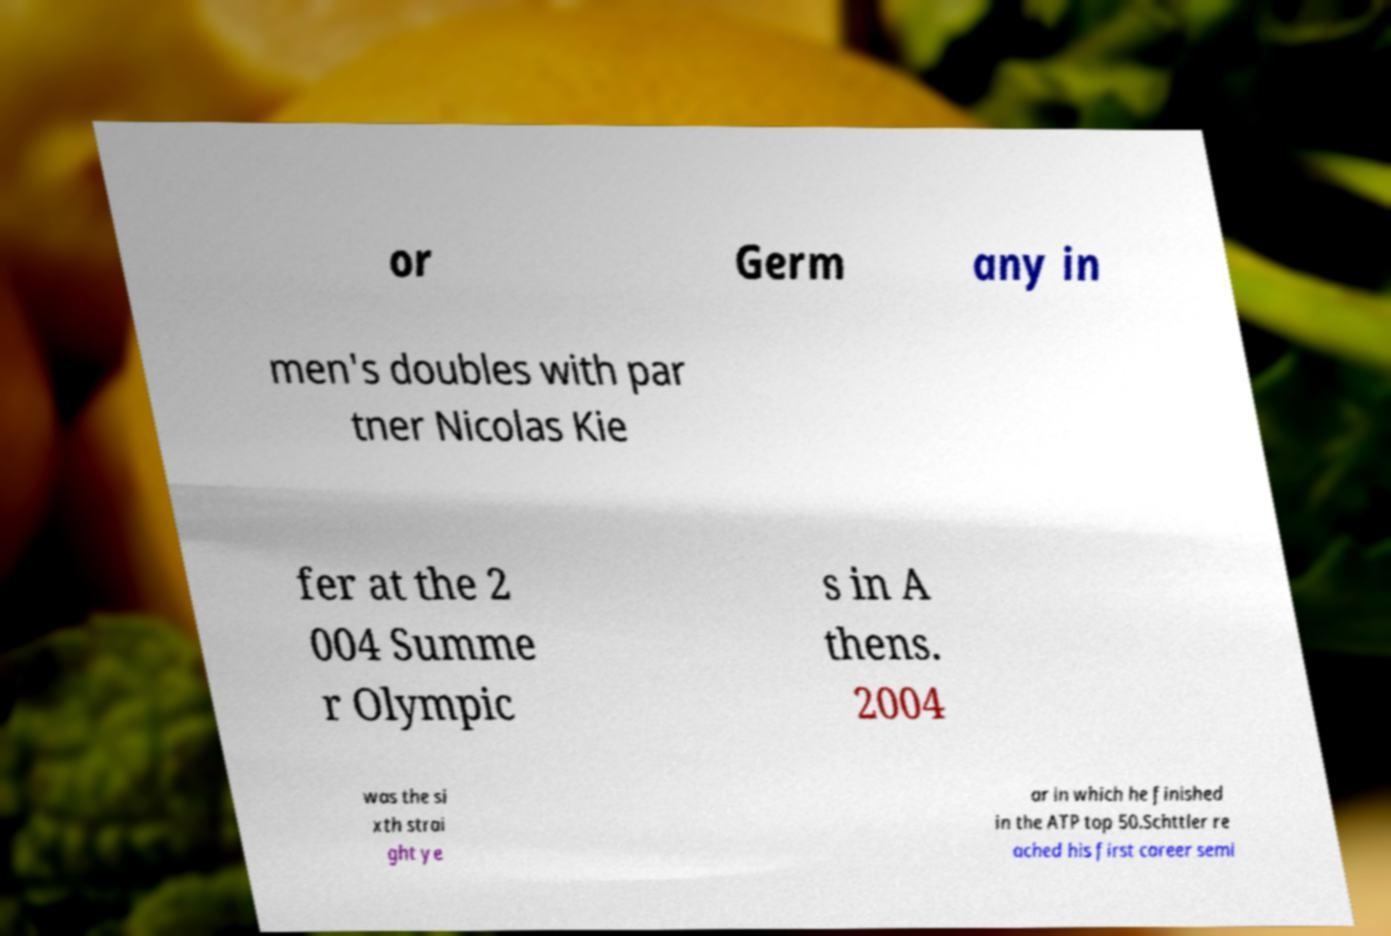Please identify and transcribe the text found in this image. or Germ any in men's doubles with par tner Nicolas Kie fer at the 2 004 Summe r Olympic s in A thens. 2004 was the si xth strai ght ye ar in which he finished in the ATP top 50.Schttler re ached his first career semi 